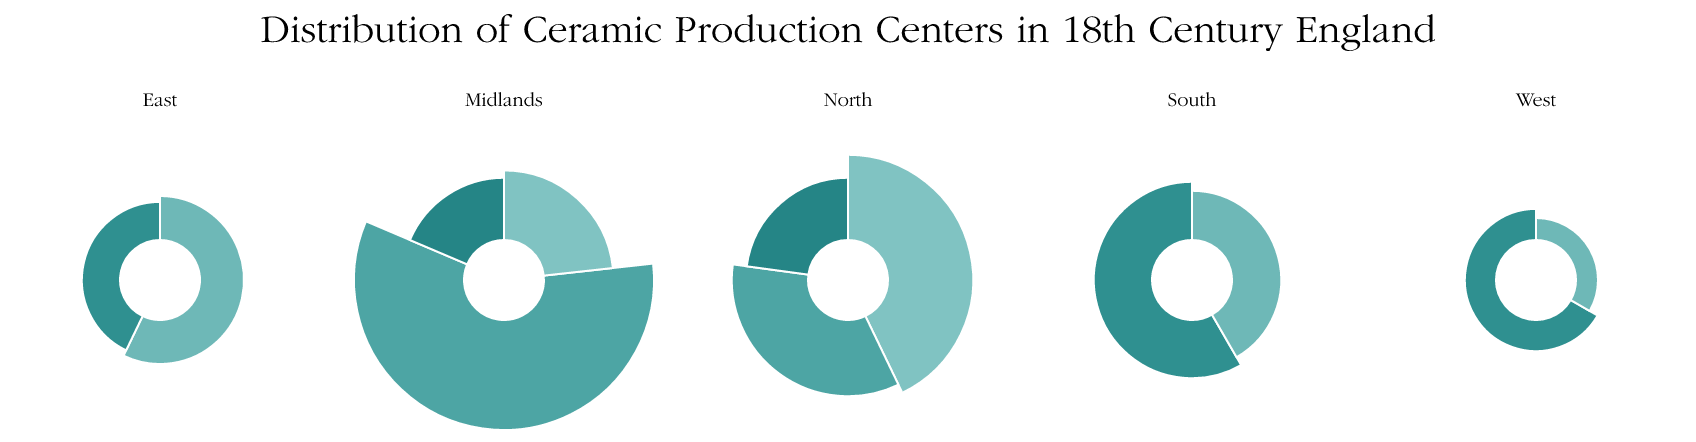Which region has the highest percentage of ceramic production? Look at the regions and add up the percentages for each; the Midlands has Stoke-on-Trent (25%), Derby (10%), and Worcester (8%) which totals 43%. This is the highest among the regions.
Answer: Midlands What is the percentage difference between Leeds and Liverpool? Look at the North region where Leeds has 15% and Liverpool has 12%. The difference is 15% - 12% = 3%.
Answer: 3% Which production center contributes the least to ceramic production? The center with the least percentage is Exeter in the West with 1%.
Answer: Exeter How many production centers are there in the North region? From the North region, we have Leeds, Liverpool, and Newcastle, which count to 3 production centers.
Answer: 3 What is the total percentage of ceramic production in the South region? Add the percentages for the South region: London (7%) and Bristol (5%). The sum is 7% + 5% = 12%.
Answer: 12% Which two production centers have the smallest combined percentage? From the data, the smallest percentages are Plymouth (2%) and Exeter (1%). Combined, 2% + 1% = 3%.
Answer: Plymouth and Exeter Which region has the most production centers? Count the production centers per region. North has Leeds, Liverpool, and Newcastle (3 centers); Midlands has Stoke-on-Trent, Derby, Worcester (3); South has London and Bristol (2); East has Lowestoft and Norwich (2); West has Plymouth and Exeter (2). North and Midlands tie with 3 each.
Answer: North & Midlands What is the total production percentage for regions with only two production centers? Calculate the total for South, East, and West regions. South: 7% (London) + 5% (Bristol) = 12%; East: 4% (Lowestoft) + 3% (Norwich) = 7%; West: 2% (Plymouth) + 1% (Exeter) = 3%. Summing these, 12% + 7% + 3% = 22%.
Answer: 22% Which production center in the Midlands contributes the least? In the Midlands, Stoke-on-Trent (25%), Derby (10%), Worcester (8%). Worcester contributes the least.
Answer: Worcester 